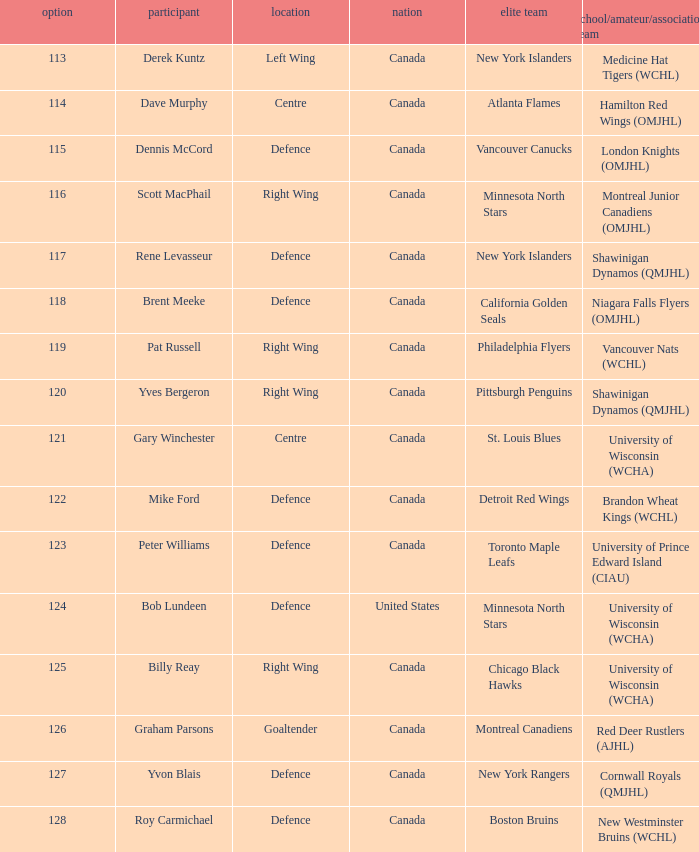Parse the table in full. {'header': ['option', 'participant', 'location', 'nation', 'elite team', 'school/amateur/association team'], 'rows': [['113', 'Derek Kuntz', 'Left Wing', 'Canada', 'New York Islanders', 'Medicine Hat Tigers (WCHL)'], ['114', 'Dave Murphy', 'Centre', 'Canada', 'Atlanta Flames', 'Hamilton Red Wings (OMJHL)'], ['115', 'Dennis McCord', 'Defence', 'Canada', 'Vancouver Canucks', 'London Knights (OMJHL)'], ['116', 'Scott MacPhail', 'Right Wing', 'Canada', 'Minnesota North Stars', 'Montreal Junior Canadiens (OMJHL)'], ['117', 'Rene Levasseur', 'Defence', 'Canada', 'New York Islanders', 'Shawinigan Dynamos (QMJHL)'], ['118', 'Brent Meeke', 'Defence', 'Canada', 'California Golden Seals', 'Niagara Falls Flyers (OMJHL)'], ['119', 'Pat Russell', 'Right Wing', 'Canada', 'Philadelphia Flyers', 'Vancouver Nats (WCHL)'], ['120', 'Yves Bergeron', 'Right Wing', 'Canada', 'Pittsburgh Penguins', 'Shawinigan Dynamos (QMJHL)'], ['121', 'Gary Winchester', 'Centre', 'Canada', 'St. Louis Blues', 'University of Wisconsin (WCHA)'], ['122', 'Mike Ford', 'Defence', 'Canada', 'Detroit Red Wings', 'Brandon Wheat Kings (WCHL)'], ['123', 'Peter Williams', 'Defence', 'Canada', 'Toronto Maple Leafs', 'University of Prince Edward Island (CIAU)'], ['124', 'Bob Lundeen', 'Defence', 'United States', 'Minnesota North Stars', 'University of Wisconsin (WCHA)'], ['125', 'Billy Reay', 'Right Wing', 'Canada', 'Chicago Black Hawks', 'University of Wisconsin (WCHA)'], ['126', 'Graham Parsons', 'Goaltender', 'Canada', 'Montreal Canadiens', 'Red Deer Rustlers (AJHL)'], ['127', 'Yvon Blais', 'Defence', 'Canada', 'New York Rangers', 'Cornwall Royals (QMJHL)'], ['128', 'Roy Carmichael', 'Defence', 'Canada', 'Boston Bruins', 'New Westminster Bruins (WCHL)']]} Name the college/junior/club team for left wing Medicine Hat Tigers (WCHL). 